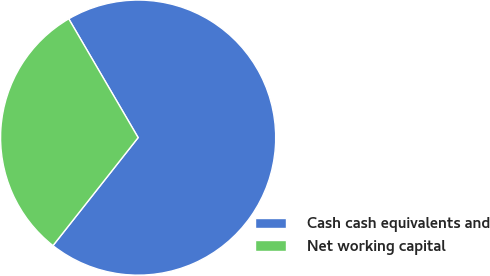Convert chart to OTSL. <chart><loc_0><loc_0><loc_500><loc_500><pie_chart><fcel>Cash cash equivalents and<fcel>Net working capital<nl><fcel>69.04%<fcel>30.96%<nl></chart> 